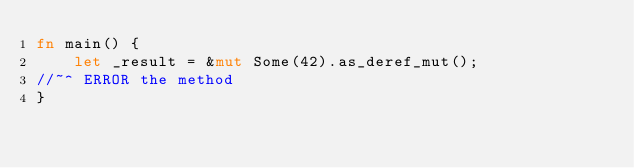<code> <loc_0><loc_0><loc_500><loc_500><_Rust_>fn main() {
    let _result = &mut Some(42).as_deref_mut();
//~^ ERROR the method
}
</code> 